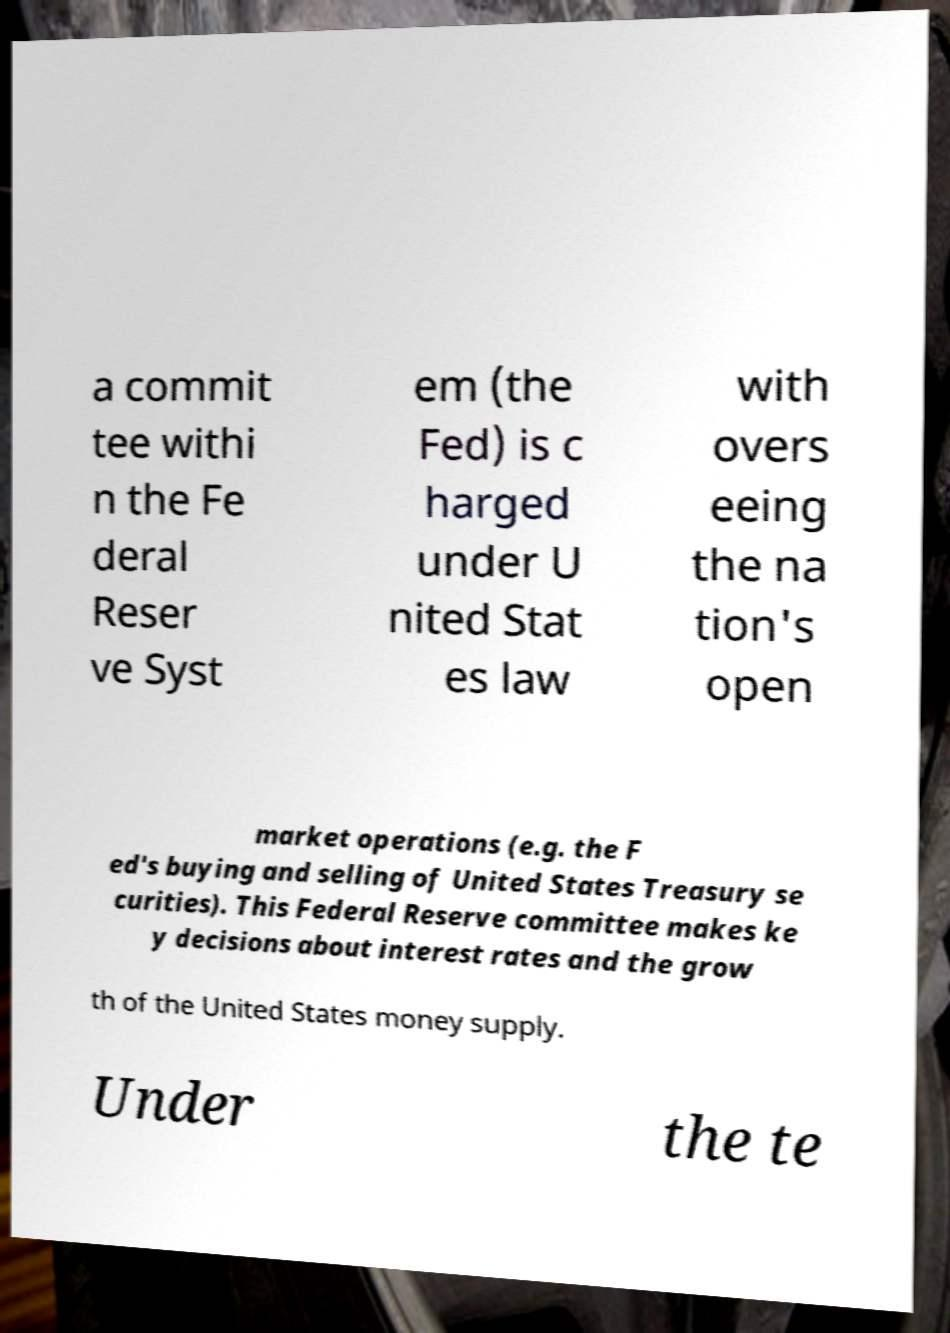Could you assist in decoding the text presented in this image and type it out clearly? a commit tee withi n the Fe deral Reser ve Syst em (the Fed) is c harged under U nited Stat es law with overs eeing the na tion's open market operations (e.g. the F ed's buying and selling of United States Treasury se curities). This Federal Reserve committee makes ke y decisions about interest rates and the grow th of the United States money supply. Under the te 